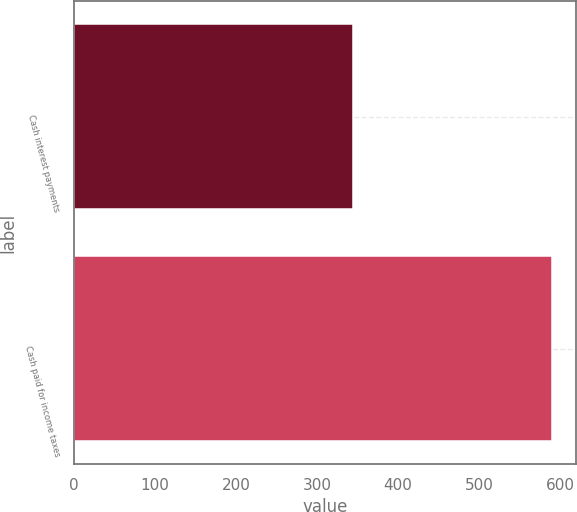<chart> <loc_0><loc_0><loc_500><loc_500><bar_chart><fcel>Cash interest payments<fcel>Cash paid for income taxes<nl><fcel>344.3<fcel>590.6<nl></chart> 